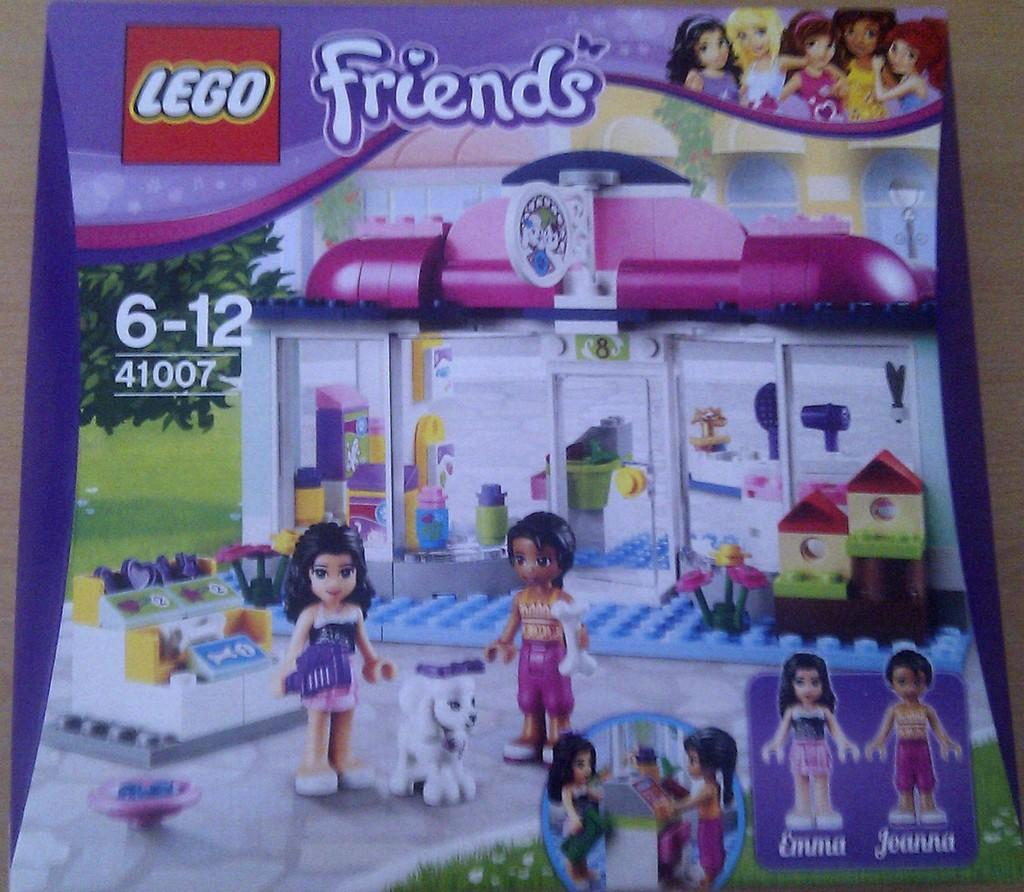What is placed on the wooden object in the image? There is a paper on a wooden object in the image. What type of objects can be seen in the image that are typically used for building and creativity? Lego boards are in the image. What other items are present in the image that might be used for play? There are toys in the image. What information can be found on the paper? There are words and numbers on the paper. What is the weight of the engine in the image? There is no engine present in the image. Who is the owner of the toys in the image? The image does not provide information about the ownership of the toys. 